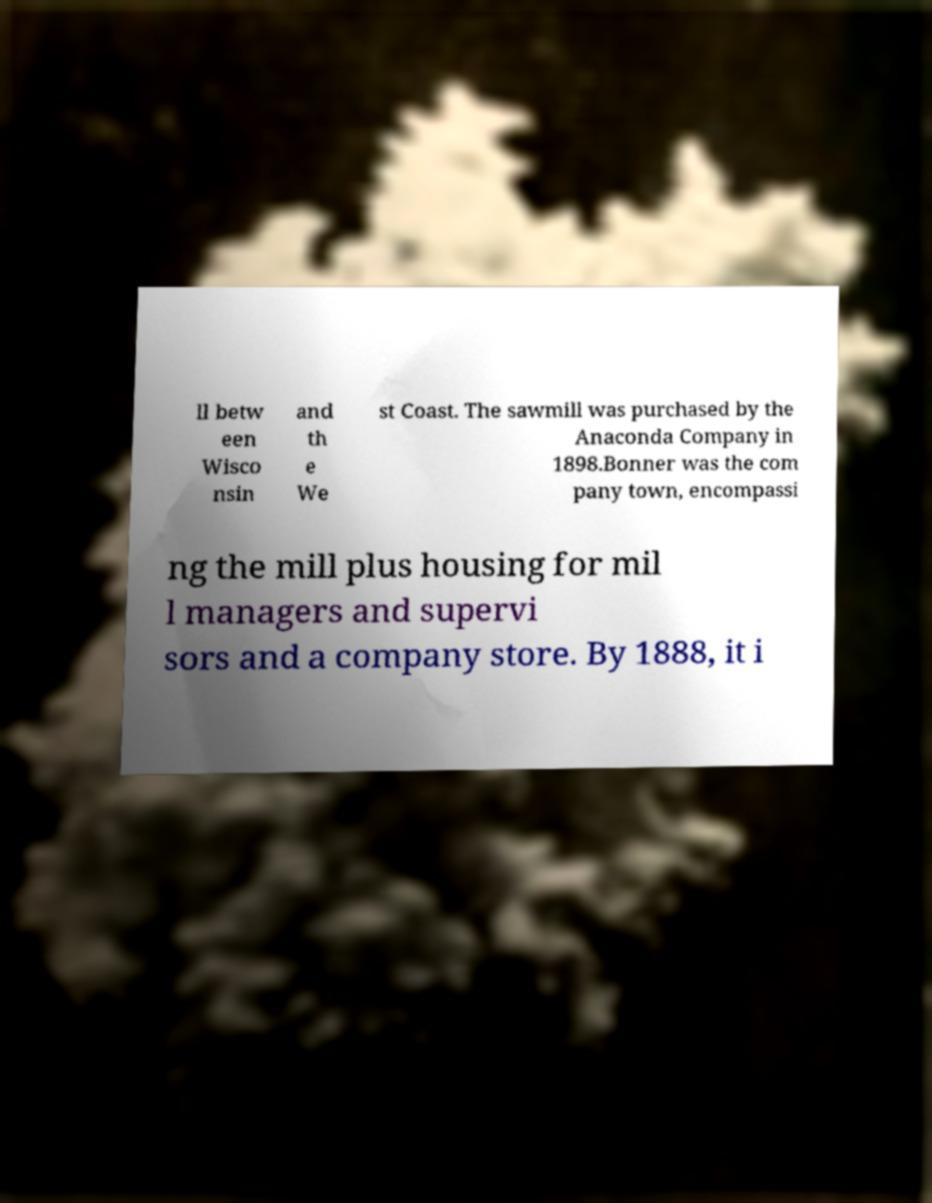For documentation purposes, I need the text within this image transcribed. Could you provide that? ll betw een Wisco nsin and th e We st Coast. The sawmill was purchased by the Anaconda Company in 1898.Bonner was the com pany town, encompassi ng the mill plus housing for mil l managers and supervi sors and a company store. By 1888, it i 